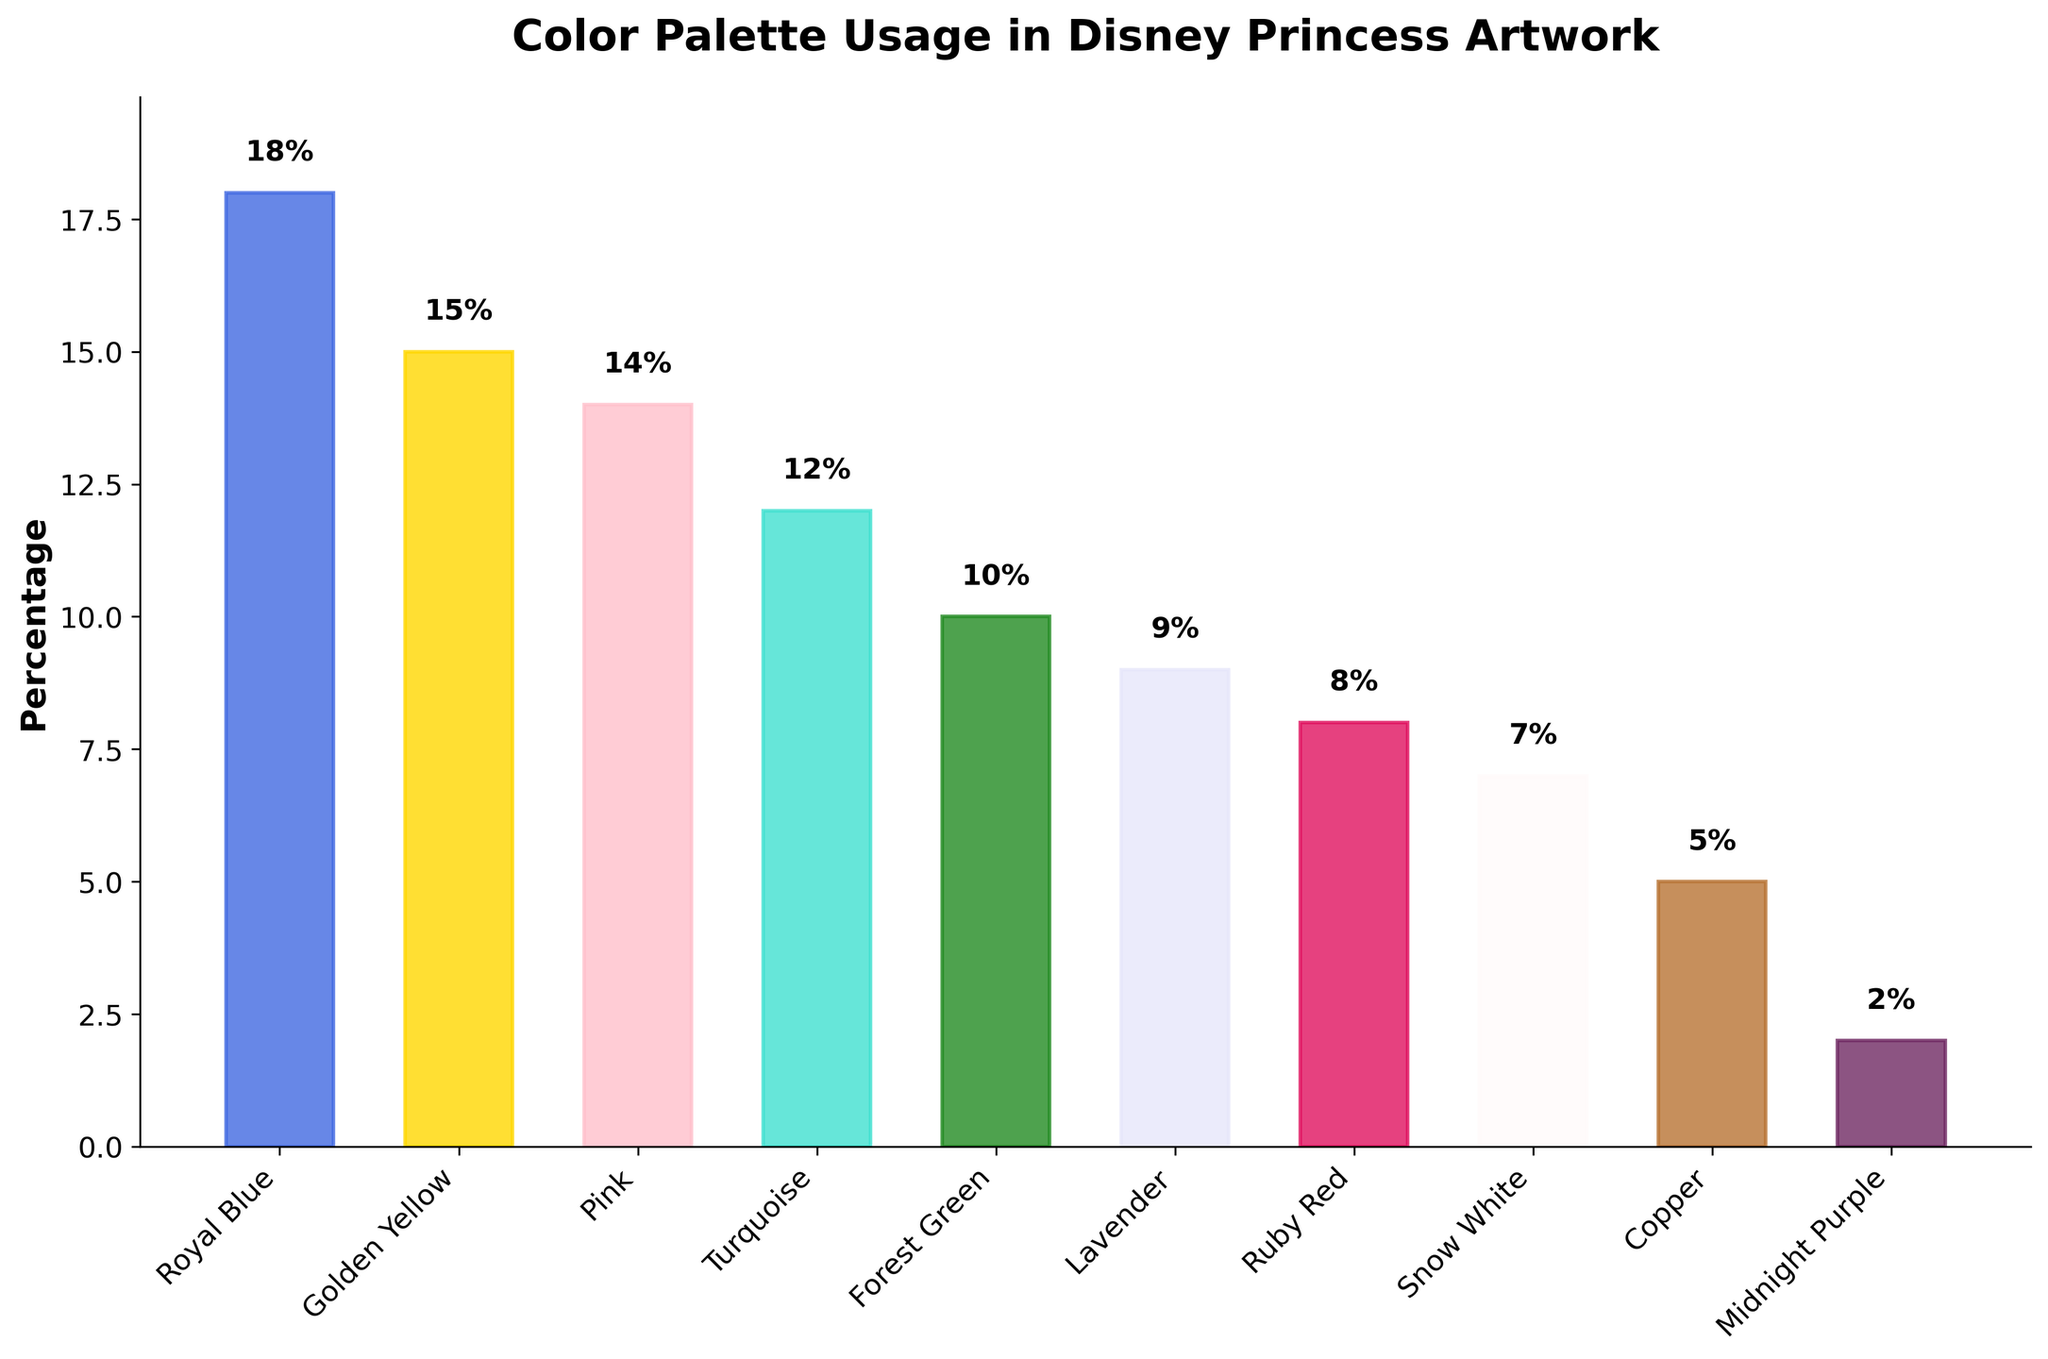Which color is used the most in Disney princess artwork? The tallest bar in the chart represents the color with the highest percentage. Royal Blue is the color with the highest percentage at 18%.
Answer: Royal Blue Which color is used the least in Disney princess artwork? The shortest bar in the chart is labeled Midnight Purple and has a percentage of 2%, indicating it is the least used color.
Answer: Midnight Purple What is the difference in the percentage usage between Royal Blue and Midnight Purple? The percentage of Royal Blue is 18% and Midnight Purple is 2%. The difference between them is 18% - 2% = 16%.
Answer: 16% How many colors have a percentage usage above 10%? By examining the bar chart, the colors with percentages above 10% are Royal Blue, Golden Yellow, Pink, Turquoise, and Forest Green. This adds up to 5 colors.
Answer: 5 Summing up Pink, Golden Yellow, and Turquoise, what is their combined usage percentage? The percentages for Pink, Golden Yellow, and Turquoise are 14%, 15%, and 12%, respectively. Adding them gives 14% + 15% + 12% = 41%.
Answer: 41% Which colors have a usage percentage of 10% or less? By looking at the bars and their labels, the colors with percentages of 10% or less are Forest Green, Lavender, Ruby Red, Snow White, Copper, and Midnight Purple.
Answer: Forest Green, Lavender, Ruby Red, Snow White, Copper, Midnight Purple Is Snow White used more frequently than Ruby Red? By comparing the heights of the bars labeled Snow White and Ruby Red, Ruby Red stands at 8% while Snow White stands at 7%. Ruby Red is used more frequently than Snow White.
Answer: No Which colors have a very similar usage percentage within a 1% difference? From the chart, comparing the percentages shows that Golden Yellow at 15% and Pink at 14% have a 1% difference.
Answer: Golden Yellow and Pink What is the average usage percentage of all the colors? Sum the percentages: 18% + 15% + 14% + 12% + 10% + 9% + 8% + 7% + 5% + 2% = 100%. Since there are 10 colors, the average is 100% / 10 = 10%.
Answer: 10% 